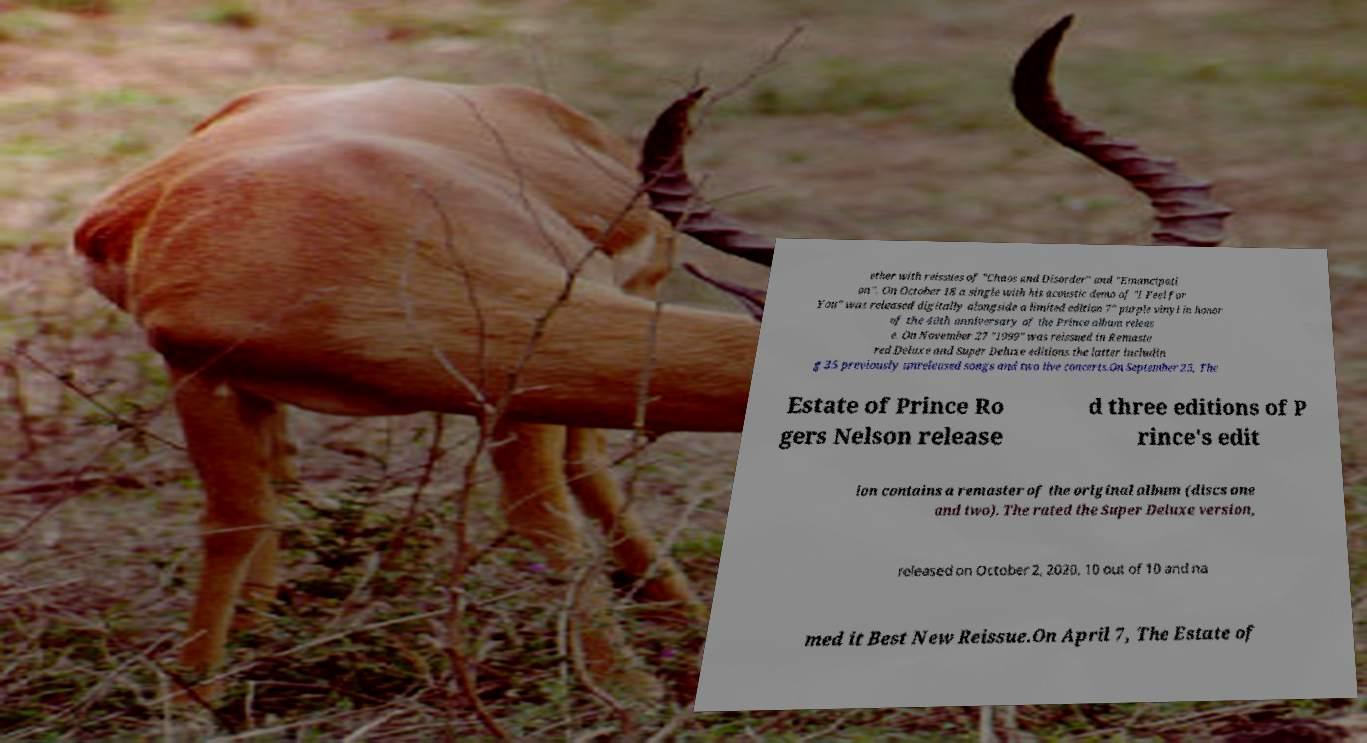There's text embedded in this image that I need extracted. Can you transcribe it verbatim? ether with reissues of "Chaos and Disorder" and "Emancipati on". On October 18 a single with his acoustic demo of "I Feel for You" was released digitally alongside a limited edition 7" purple vinyl in honor of the 40th anniversary of the Prince album releas e. On November 27 "1999" was reissued in Remaste red Deluxe and Super Deluxe editions the latter includin g 35 previously unreleased songs and two live concerts.On September 25, The Estate of Prince Ro gers Nelson release d three editions of P rince's edit ion contains a remaster of the original album (discs one and two). The rated the Super Deluxe version, released on October 2, 2020, 10 out of 10 and na med it Best New Reissue.On April 7, The Estate of 